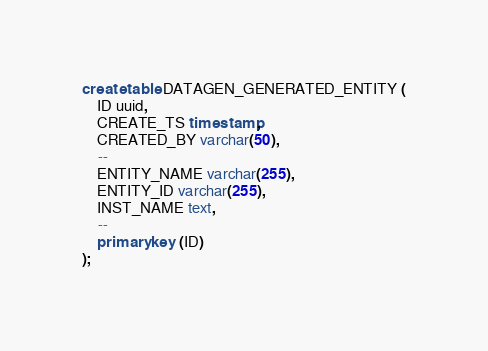<code> <loc_0><loc_0><loc_500><loc_500><_SQL_>create table DATAGEN_GENERATED_ENTITY (
    ID uuid,
    CREATE_TS timestamp,
    CREATED_BY varchar(50),
    --
    ENTITY_NAME varchar(255),
    ENTITY_ID varchar(255),
    INST_NAME text,
    --
    primary key (ID)
);</code> 